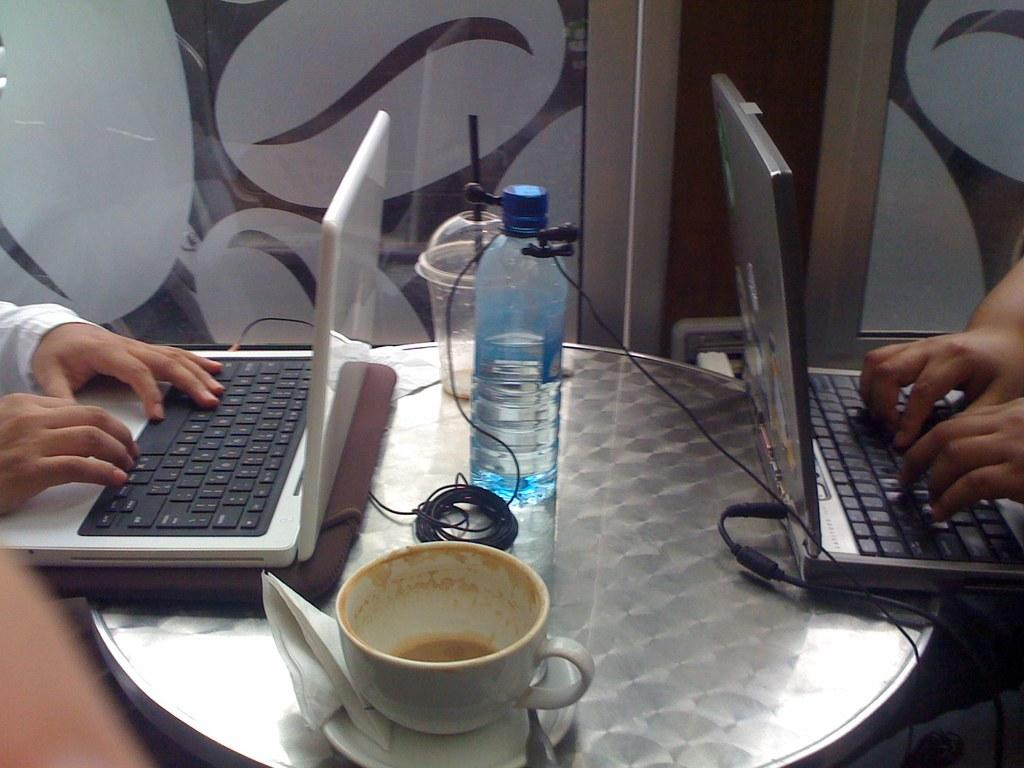How many people are in the image? There are two persons in the image. What are the two persons doing in the image? The two persons are operating laptops. Where are the laptops placed in the image? The laptops are placed on a table. What else can be seen on the table in the image? There is a water bottle and other objects on the table. What type of eggs can be seen in the image? There are no eggs present in the image. What discovery did the two persons make while operating their laptops in the image? The image does not provide any information about a discovery made by the two persons. 